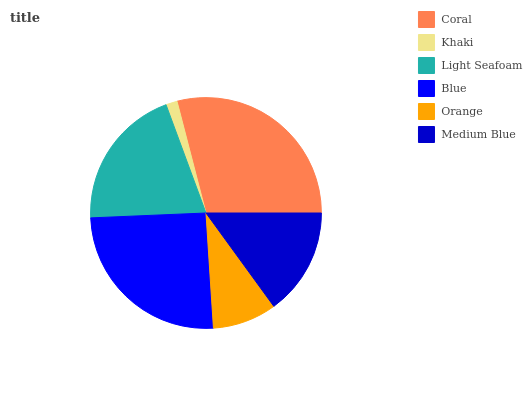Is Khaki the minimum?
Answer yes or no. Yes. Is Coral the maximum?
Answer yes or no. Yes. Is Light Seafoam the minimum?
Answer yes or no. No. Is Light Seafoam the maximum?
Answer yes or no. No. Is Light Seafoam greater than Khaki?
Answer yes or no. Yes. Is Khaki less than Light Seafoam?
Answer yes or no. Yes. Is Khaki greater than Light Seafoam?
Answer yes or no. No. Is Light Seafoam less than Khaki?
Answer yes or no. No. Is Light Seafoam the high median?
Answer yes or no. Yes. Is Medium Blue the low median?
Answer yes or no. Yes. Is Coral the high median?
Answer yes or no. No. Is Khaki the low median?
Answer yes or no. No. 